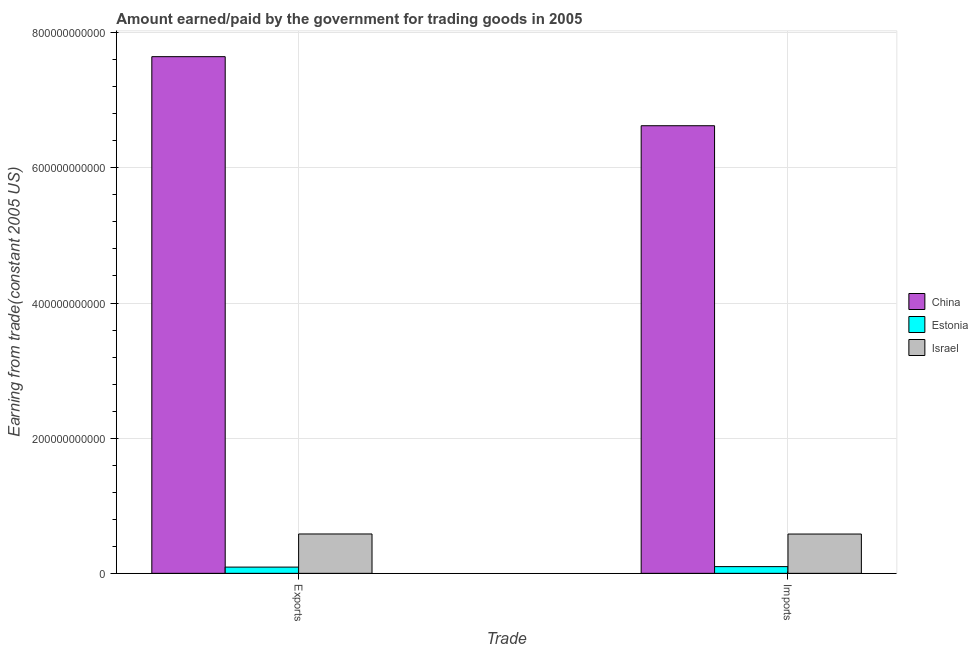How many different coloured bars are there?
Provide a short and direct response. 3. Are the number of bars per tick equal to the number of legend labels?
Your response must be concise. Yes. How many bars are there on the 2nd tick from the right?
Provide a succinct answer. 3. What is the label of the 2nd group of bars from the left?
Your answer should be very brief. Imports. What is the amount earned from exports in China?
Provide a succinct answer. 7.65e+11. Across all countries, what is the maximum amount paid for imports?
Make the answer very short. 6.62e+11. Across all countries, what is the minimum amount paid for imports?
Keep it short and to the point. 9.95e+09. In which country was the amount earned from exports maximum?
Your answer should be very brief. China. In which country was the amount earned from exports minimum?
Offer a very short reply. Estonia. What is the total amount earned from exports in the graph?
Offer a terse response. 8.32e+11. What is the difference between the amount earned from exports in Israel and that in China?
Keep it short and to the point. -7.06e+11. What is the difference between the amount earned from exports in Israel and the amount paid for imports in China?
Keep it short and to the point. -6.04e+11. What is the average amount paid for imports per country?
Your response must be concise. 2.43e+11. What is the difference between the amount paid for imports and amount earned from exports in Israel?
Provide a succinct answer. -9.23e+07. In how many countries, is the amount paid for imports greater than 400000000000 US$?
Your response must be concise. 1. What is the ratio of the amount earned from exports in China to that in Israel?
Your answer should be very brief. 13.13. Is the amount paid for imports in China less than that in Israel?
Offer a very short reply. No. In how many countries, is the amount earned from exports greater than the average amount earned from exports taken over all countries?
Keep it short and to the point. 1. What does the 2nd bar from the left in Exports represents?
Your response must be concise. Estonia. What does the 2nd bar from the right in Imports represents?
Ensure brevity in your answer.  Estonia. How many bars are there?
Offer a terse response. 6. Are all the bars in the graph horizontal?
Your answer should be very brief. No. How many countries are there in the graph?
Provide a succinct answer. 3. What is the difference between two consecutive major ticks on the Y-axis?
Provide a short and direct response. 2.00e+11. Are the values on the major ticks of Y-axis written in scientific E-notation?
Provide a succinct answer. No. What is the title of the graph?
Offer a very short reply. Amount earned/paid by the government for trading goods in 2005. Does "High income: nonOECD" appear as one of the legend labels in the graph?
Ensure brevity in your answer.  No. What is the label or title of the X-axis?
Your answer should be compact. Trade. What is the label or title of the Y-axis?
Your answer should be compact. Earning from trade(constant 2005 US). What is the Earning from trade(constant 2005 US) in China in Exports?
Offer a very short reply. 7.65e+11. What is the Earning from trade(constant 2005 US) of Estonia in Exports?
Your answer should be very brief. 9.23e+09. What is the Earning from trade(constant 2005 US) of Israel in Exports?
Make the answer very short. 5.82e+1. What is the Earning from trade(constant 2005 US) of China in Imports?
Provide a short and direct response. 6.62e+11. What is the Earning from trade(constant 2005 US) in Estonia in Imports?
Give a very brief answer. 9.95e+09. What is the Earning from trade(constant 2005 US) in Israel in Imports?
Provide a short and direct response. 5.81e+1. Across all Trade, what is the maximum Earning from trade(constant 2005 US) of China?
Make the answer very short. 7.65e+11. Across all Trade, what is the maximum Earning from trade(constant 2005 US) in Estonia?
Your answer should be very brief. 9.95e+09. Across all Trade, what is the maximum Earning from trade(constant 2005 US) in Israel?
Your answer should be very brief. 5.82e+1. Across all Trade, what is the minimum Earning from trade(constant 2005 US) of China?
Your answer should be very brief. 6.62e+11. Across all Trade, what is the minimum Earning from trade(constant 2005 US) in Estonia?
Your answer should be very brief. 9.23e+09. Across all Trade, what is the minimum Earning from trade(constant 2005 US) of Israel?
Make the answer very short. 5.81e+1. What is the total Earning from trade(constant 2005 US) in China in the graph?
Your response must be concise. 1.43e+12. What is the total Earning from trade(constant 2005 US) of Estonia in the graph?
Provide a succinct answer. 1.92e+1. What is the total Earning from trade(constant 2005 US) of Israel in the graph?
Offer a terse response. 1.16e+11. What is the difference between the Earning from trade(constant 2005 US) in China in Exports and that in Imports?
Offer a terse response. 1.02e+11. What is the difference between the Earning from trade(constant 2005 US) of Estonia in Exports and that in Imports?
Give a very brief answer. -7.15e+08. What is the difference between the Earning from trade(constant 2005 US) of Israel in Exports and that in Imports?
Provide a short and direct response. 9.23e+07. What is the difference between the Earning from trade(constant 2005 US) in China in Exports and the Earning from trade(constant 2005 US) in Estonia in Imports?
Make the answer very short. 7.55e+11. What is the difference between the Earning from trade(constant 2005 US) of China in Exports and the Earning from trade(constant 2005 US) of Israel in Imports?
Make the answer very short. 7.06e+11. What is the difference between the Earning from trade(constant 2005 US) of Estonia in Exports and the Earning from trade(constant 2005 US) of Israel in Imports?
Ensure brevity in your answer.  -4.89e+1. What is the average Earning from trade(constant 2005 US) in China per Trade?
Your answer should be compact. 7.13e+11. What is the average Earning from trade(constant 2005 US) in Estonia per Trade?
Your answer should be compact. 9.59e+09. What is the average Earning from trade(constant 2005 US) in Israel per Trade?
Provide a succinct answer. 5.82e+1. What is the difference between the Earning from trade(constant 2005 US) of China and Earning from trade(constant 2005 US) of Estonia in Exports?
Offer a very short reply. 7.55e+11. What is the difference between the Earning from trade(constant 2005 US) of China and Earning from trade(constant 2005 US) of Israel in Exports?
Give a very brief answer. 7.06e+11. What is the difference between the Earning from trade(constant 2005 US) in Estonia and Earning from trade(constant 2005 US) in Israel in Exports?
Offer a terse response. -4.90e+1. What is the difference between the Earning from trade(constant 2005 US) in China and Earning from trade(constant 2005 US) in Estonia in Imports?
Your answer should be compact. 6.52e+11. What is the difference between the Earning from trade(constant 2005 US) of China and Earning from trade(constant 2005 US) of Israel in Imports?
Offer a very short reply. 6.04e+11. What is the difference between the Earning from trade(constant 2005 US) of Estonia and Earning from trade(constant 2005 US) of Israel in Imports?
Provide a short and direct response. -4.82e+1. What is the ratio of the Earning from trade(constant 2005 US) in China in Exports to that in Imports?
Offer a terse response. 1.15. What is the ratio of the Earning from trade(constant 2005 US) of Estonia in Exports to that in Imports?
Offer a terse response. 0.93. What is the difference between the highest and the second highest Earning from trade(constant 2005 US) of China?
Offer a terse response. 1.02e+11. What is the difference between the highest and the second highest Earning from trade(constant 2005 US) of Estonia?
Keep it short and to the point. 7.15e+08. What is the difference between the highest and the second highest Earning from trade(constant 2005 US) of Israel?
Ensure brevity in your answer.  9.23e+07. What is the difference between the highest and the lowest Earning from trade(constant 2005 US) in China?
Provide a short and direct response. 1.02e+11. What is the difference between the highest and the lowest Earning from trade(constant 2005 US) in Estonia?
Make the answer very short. 7.15e+08. What is the difference between the highest and the lowest Earning from trade(constant 2005 US) of Israel?
Offer a terse response. 9.23e+07. 